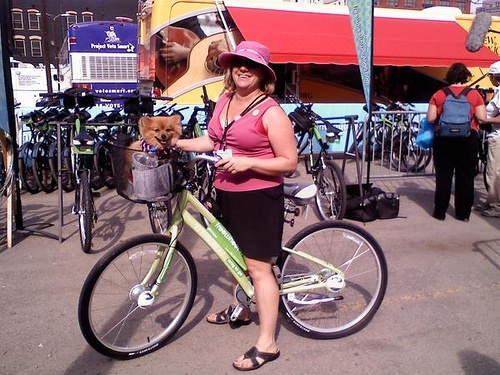Describe the objects in this image and their specific colors. I can see bicycle in black, darkgray, gray, and lightgray tones, people in black, lightpink, maroon, and violet tones, people in black, gray, navy, and maroon tones, bus in black, lavender, darkblue, darkgray, and purple tones, and bicycle in black, gray, darkgray, and purple tones in this image. 